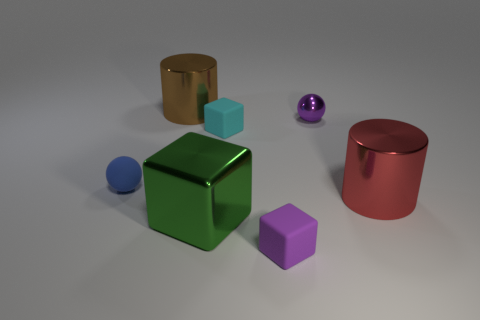Add 3 shiny cubes. How many objects exist? 10 Subtract all cylinders. How many objects are left? 5 Add 6 rubber objects. How many rubber objects are left? 9 Add 4 cyan rubber things. How many cyan rubber things exist? 5 Subtract 0 red spheres. How many objects are left? 7 Subtract all big green metal cubes. Subtract all big shiny cylinders. How many objects are left? 4 